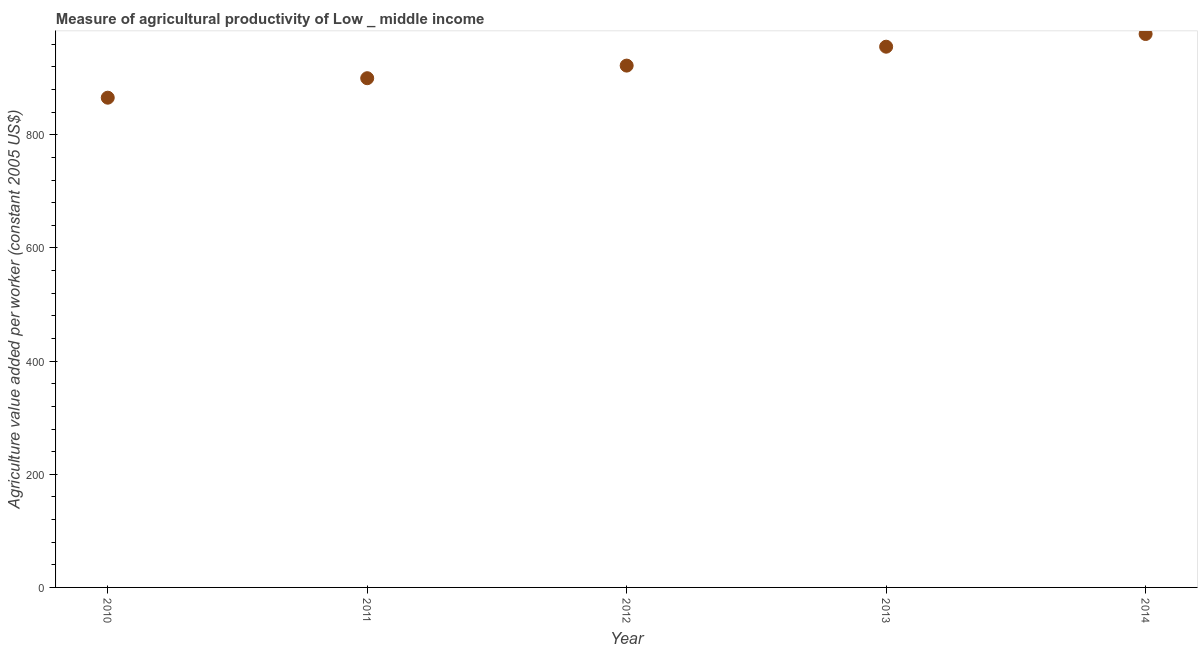What is the agriculture value added per worker in 2013?
Ensure brevity in your answer.  955.78. Across all years, what is the maximum agriculture value added per worker?
Offer a terse response. 978.2. Across all years, what is the minimum agriculture value added per worker?
Make the answer very short. 865.64. In which year was the agriculture value added per worker maximum?
Provide a succinct answer. 2014. In which year was the agriculture value added per worker minimum?
Your answer should be very brief. 2010. What is the sum of the agriculture value added per worker?
Make the answer very short. 4622.06. What is the difference between the agriculture value added per worker in 2010 and 2013?
Ensure brevity in your answer.  -90.14. What is the average agriculture value added per worker per year?
Your response must be concise. 924.41. What is the median agriculture value added per worker?
Give a very brief answer. 922.36. In how many years, is the agriculture value added per worker greater than 560 US$?
Offer a very short reply. 5. What is the ratio of the agriculture value added per worker in 2010 to that in 2013?
Give a very brief answer. 0.91. Is the agriculture value added per worker in 2011 less than that in 2013?
Provide a succinct answer. Yes. What is the difference between the highest and the second highest agriculture value added per worker?
Make the answer very short. 22.42. Is the sum of the agriculture value added per worker in 2011 and 2014 greater than the maximum agriculture value added per worker across all years?
Your answer should be very brief. Yes. What is the difference between the highest and the lowest agriculture value added per worker?
Offer a terse response. 112.56. In how many years, is the agriculture value added per worker greater than the average agriculture value added per worker taken over all years?
Offer a terse response. 2. How many years are there in the graph?
Give a very brief answer. 5. What is the title of the graph?
Your response must be concise. Measure of agricultural productivity of Low _ middle income. What is the label or title of the Y-axis?
Give a very brief answer. Agriculture value added per worker (constant 2005 US$). What is the Agriculture value added per worker (constant 2005 US$) in 2010?
Give a very brief answer. 865.64. What is the Agriculture value added per worker (constant 2005 US$) in 2011?
Provide a succinct answer. 900.08. What is the Agriculture value added per worker (constant 2005 US$) in 2012?
Offer a very short reply. 922.36. What is the Agriculture value added per worker (constant 2005 US$) in 2013?
Your response must be concise. 955.78. What is the Agriculture value added per worker (constant 2005 US$) in 2014?
Provide a succinct answer. 978.2. What is the difference between the Agriculture value added per worker (constant 2005 US$) in 2010 and 2011?
Give a very brief answer. -34.44. What is the difference between the Agriculture value added per worker (constant 2005 US$) in 2010 and 2012?
Provide a short and direct response. -56.72. What is the difference between the Agriculture value added per worker (constant 2005 US$) in 2010 and 2013?
Your response must be concise. -90.14. What is the difference between the Agriculture value added per worker (constant 2005 US$) in 2010 and 2014?
Provide a succinct answer. -112.56. What is the difference between the Agriculture value added per worker (constant 2005 US$) in 2011 and 2012?
Your answer should be very brief. -22.28. What is the difference between the Agriculture value added per worker (constant 2005 US$) in 2011 and 2013?
Ensure brevity in your answer.  -55.7. What is the difference between the Agriculture value added per worker (constant 2005 US$) in 2011 and 2014?
Your response must be concise. -78.12. What is the difference between the Agriculture value added per worker (constant 2005 US$) in 2012 and 2013?
Your answer should be very brief. -33.42. What is the difference between the Agriculture value added per worker (constant 2005 US$) in 2012 and 2014?
Keep it short and to the point. -55.84. What is the difference between the Agriculture value added per worker (constant 2005 US$) in 2013 and 2014?
Offer a very short reply. -22.42. What is the ratio of the Agriculture value added per worker (constant 2005 US$) in 2010 to that in 2011?
Keep it short and to the point. 0.96. What is the ratio of the Agriculture value added per worker (constant 2005 US$) in 2010 to that in 2012?
Make the answer very short. 0.94. What is the ratio of the Agriculture value added per worker (constant 2005 US$) in 2010 to that in 2013?
Provide a short and direct response. 0.91. What is the ratio of the Agriculture value added per worker (constant 2005 US$) in 2010 to that in 2014?
Your answer should be compact. 0.89. What is the ratio of the Agriculture value added per worker (constant 2005 US$) in 2011 to that in 2013?
Ensure brevity in your answer.  0.94. What is the ratio of the Agriculture value added per worker (constant 2005 US$) in 2012 to that in 2013?
Offer a terse response. 0.96. What is the ratio of the Agriculture value added per worker (constant 2005 US$) in 2012 to that in 2014?
Your answer should be very brief. 0.94. 